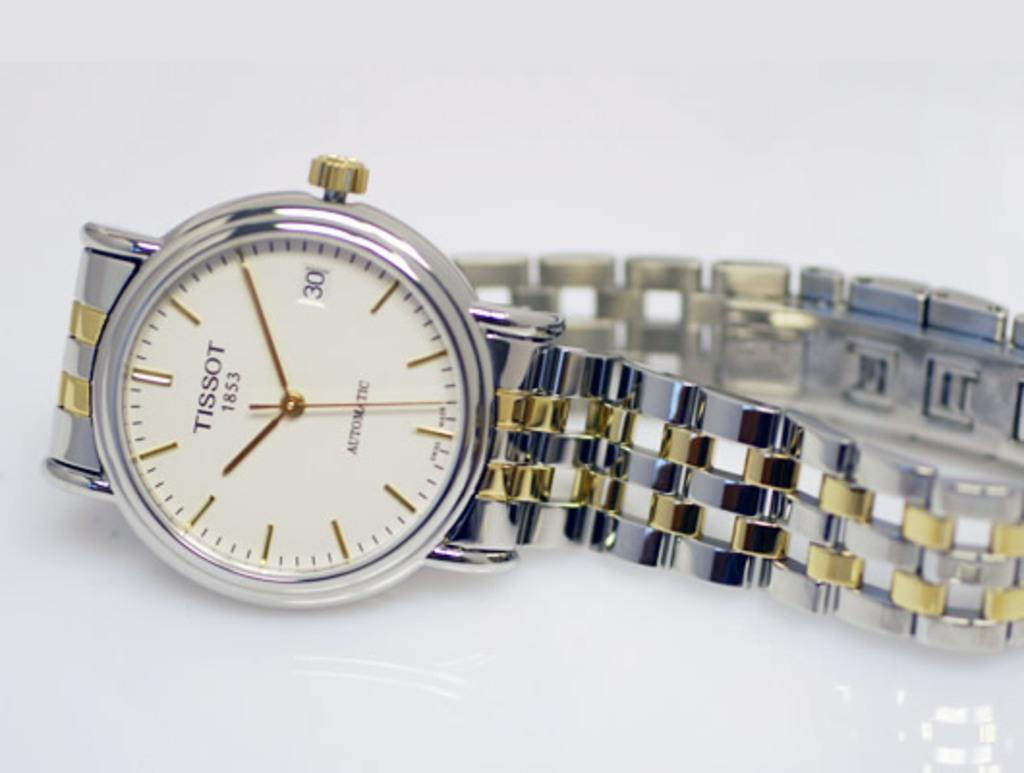Provide a one-sentence caption for the provided image. A silver and gold watch that says Tissot 1853. 